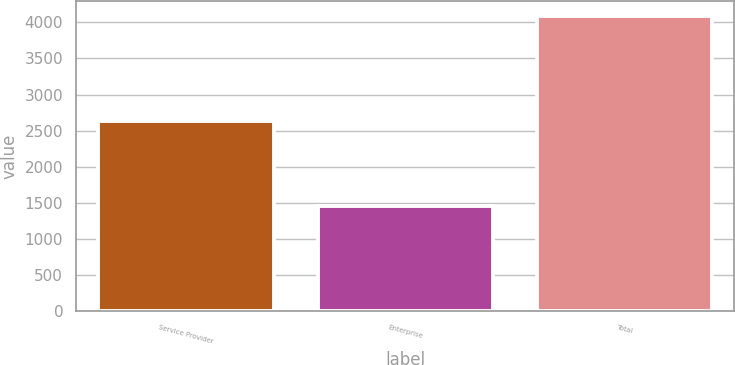<chart> <loc_0><loc_0><loc_500><loc_500><bar_chart><fcel>Service Provider<fcel>Enterprise<fcel>Total<nl><fcel>2631.5<fcel>1461.8<fcel>4093.3<nl></chart> 